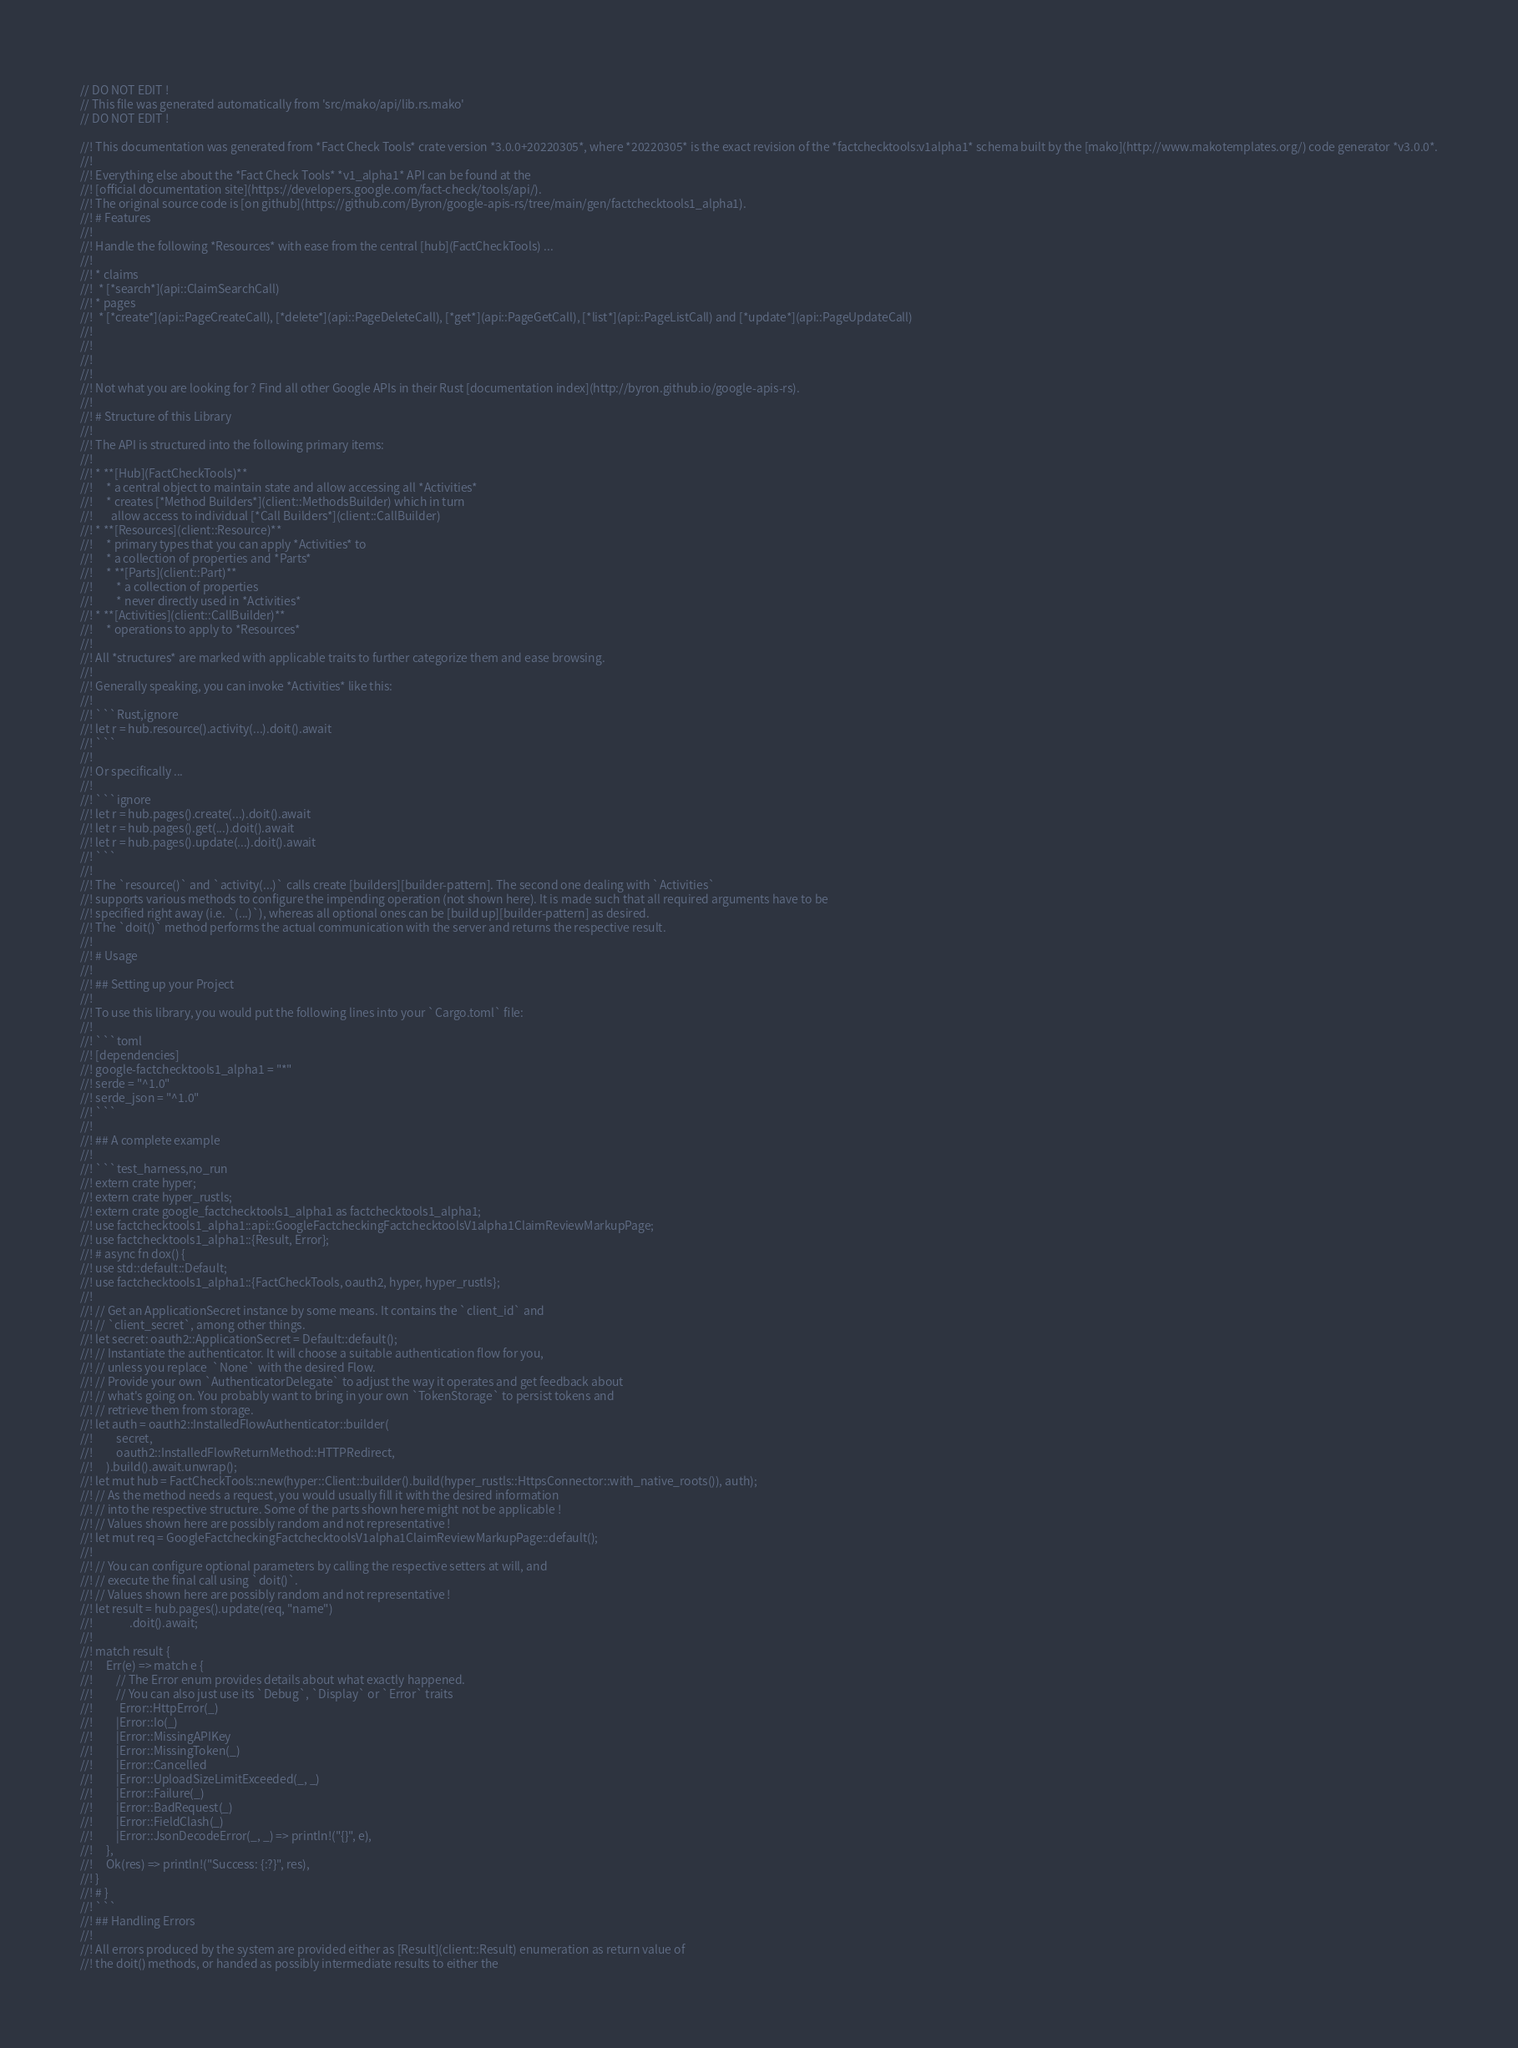<code> <loc_0><loc_0><loc_500><loc_500><_Rust_>// DO NOT EDIT !
// This file was generated automatically from 'src/mako/api/lib.rs.mako'
// DO NOT EDIT !

//! This documentation was generated from *Fact Check Tools* crate version *3.0.0+20220305*, where *20220305* is the exact revision of the *factchecktools:v1alpha1* schema built by the [mako](http://www.makotemplates.org/) code generator *v3.0.0*.
//! 
//! Everything else about the *Fact Check Tools* *v1_alpha1* API can be found at the
//! [official documentation site](https://developers.google.com/fact-check/tools/api/).
//! The original source code is [on github](https://github.com/Byron/google-apis-rs/tree/main/gen/factchecktools1_alpha1).
//! # Features
//! 
//! Handle the following *Resources* with ease from the central [hub](FactCheckTools) ... 
//! 
//! * claims
//!  * [*search*](api::ClaimSearchCall)
//! * pages
//!  * [*create*](api::PageCreateCall), [*delete*](api::PageDeleteCall), [*get*](api::PageGetCall), [*list*](api::PageListCall) and [*update*](api::PageUpdateCall)
//! 
//! 
//! 
//! 
//! Not what you are looking for ? Find all other Google APIs in their Rust [documentation index](http://byron.github.io/google-apis-rs).
//! 
//! # Structure of this Library
//! 
//! The API is structured into the following primary items:
//! 
//! * **[Hub](FactCheckTools)**
//!     * a central object to maintain state and allow accessing all *Activities*
//!     * creates [*Method Builders*](client::MethodsBuilder) which in turn
//!       allow access to individual [*Call Builders*](client::CallBuilder)
//! * **[Resources](client::Resource)**
//!     * primary types that you can apply *Activities* to
//!     * a collection of properties and *Parts*
//!     * **[Parts](client::Part)**
//!         * a collection of properties
//!         * never directly used in *Activities*
//! * **[Activities](client::CallBuilder)**
//!     * operations to apply to *Resources*
//! 
//! All *structures* are marked with applicable traits to further categorize them and ease browsing.
//! 
//! Generally speaking, you can invoke *Activities* like this:
//! 
//! ```Rust,ignore
//! let r = hub.resource().activity(...).doit().await
//! ```
//! 
//! Or specifically ...
//! 
//! ```ignore
//! let r = hub.pages().create(...).doit().await
//! let r = hub.pages().get(...).doit().await
//! let r = hub.pages().update(...).doit().await
//! ```
//! 
//! The `resource()` and `activity(...)` calls create [builders][builder-pattern]. The second one dealing with `Activities` 
//! supports various methods to configure the impending operation (not shown here). It is made such that all required arguments have to be 
//! specified right away (i.e. `(...)`), whereas all optional ones can be [build up][builder-pattern] as desired.
//! The `doit()` method performs the actual communication with the server and returns the respective result.
//! 
//! # Usage
//! 
//! ## Setting up your Project
//! 
//! To use this library, you would put the following lines into your `Cargo.toml` file:
//! 
//! ```toml
//! [dependencies]
//! google-factchecktools1_alpha1 = "*"
//! serde = "^1.0"
//! serde_json = "^1.0"
//! ```
//! 
//! ## A complete example
//! 
//! ```test_harness,no_run
//! extern crate hyper;
//! extern crate hyper_rustls;
//! extern crate google_factchecktools1_alpha1 as factchecktools1_alpha1;
//! use factchecktools1_alpha1::api::GoogleFactcheckingFactchecktoolsV1alpha1ClaimReviewMarkupPage;
//! use factchecktools1_alpha1::{Result, Error};
//! # async fn dox() {
//! use std::default::Default;
//! use factchecktools1_alpha1::{FactCheckTools, oauth2, hyper, hyper_rustls};
//! 
//! // Get an ApplicationSecret instance by some means. It contains the `client_id` and 
//! // `client_secret`, among other things.
//! let secret: oauth2::ApplicationSecret = Default::default();
//! // Instantiate the authenticator. It will choose a suitable authentication flow for you, 
//! // unless you replace  `None` with the desired Flow.
//! // Provide your own `AuthenticatorDelegate` to adjust the way it operates and get feedback about 
//! // what's going on. You probably want to bring in your own `TokenStorage` to persist tokens and
//! // retrieve them from storage.
//! let auth = oauth2::InstalledFlowAuthenticator::builder(
//!         secret,
//!         oauth2::InstalledFlowReturnMethod::HTTPRedirect,
//!     ).build().await.unwrap();
//! let mut hub = FactCheckTools::new(hyper::Client::builder().build(hyper_rustls::HttpsConnector::with_native_roots()), auth);
//! // As the method needs a request, you would usually fill it with the desired information
//! // into the respective structure. Some of the parts shown here might not be applicable !
//! // Values shown here are possibly random and not representative !
//! let mut req = GoogleFactcheckingFactchecktoolsV1alpha1ClaimReviewMarkupPage::default();
//! 
//! // You can configure optional parameters by calling the respective setters at will, and
//! // execute the final call using `doit()`.
//! // Values shown here are possibly random and not representative !
//! let result = hub.pages().update(req, "name")
//!              .doit().await;
//! 
//! match result {
//!     Err(e) => match e {
//!         // The Error enum provides details about what exactly happened.
//!         // You can also just use its `Debug`, `Display` or `Error` traits
//!          Error::HttpError(_)
//!         |Error::Io(_)
//!         |Error::MissingAPIKey
//!         |Error::MissingToken(_)
//!         |Error::Cancelled
//!         |Error::UploadSizeLimitExceeded(_, _)
//!         |Error::Failure(_)
//!         |Error::BadRequest(_)
//!         |Error::FieldClash(_)
//!         |Error::JsonDecodeError(_, _) => println!("{}", e),
//!     },
//!     Ok(res) => println!("Success: {:?}", res),
//! }
//! # }
//! ```
//! ## Handling Errors
//! 
//! All errors produced by the system are provided either as [Result](client::Result) enumeration as return value of
//! the doit() methods, or handed as possibly intermediate results to either the </code> 